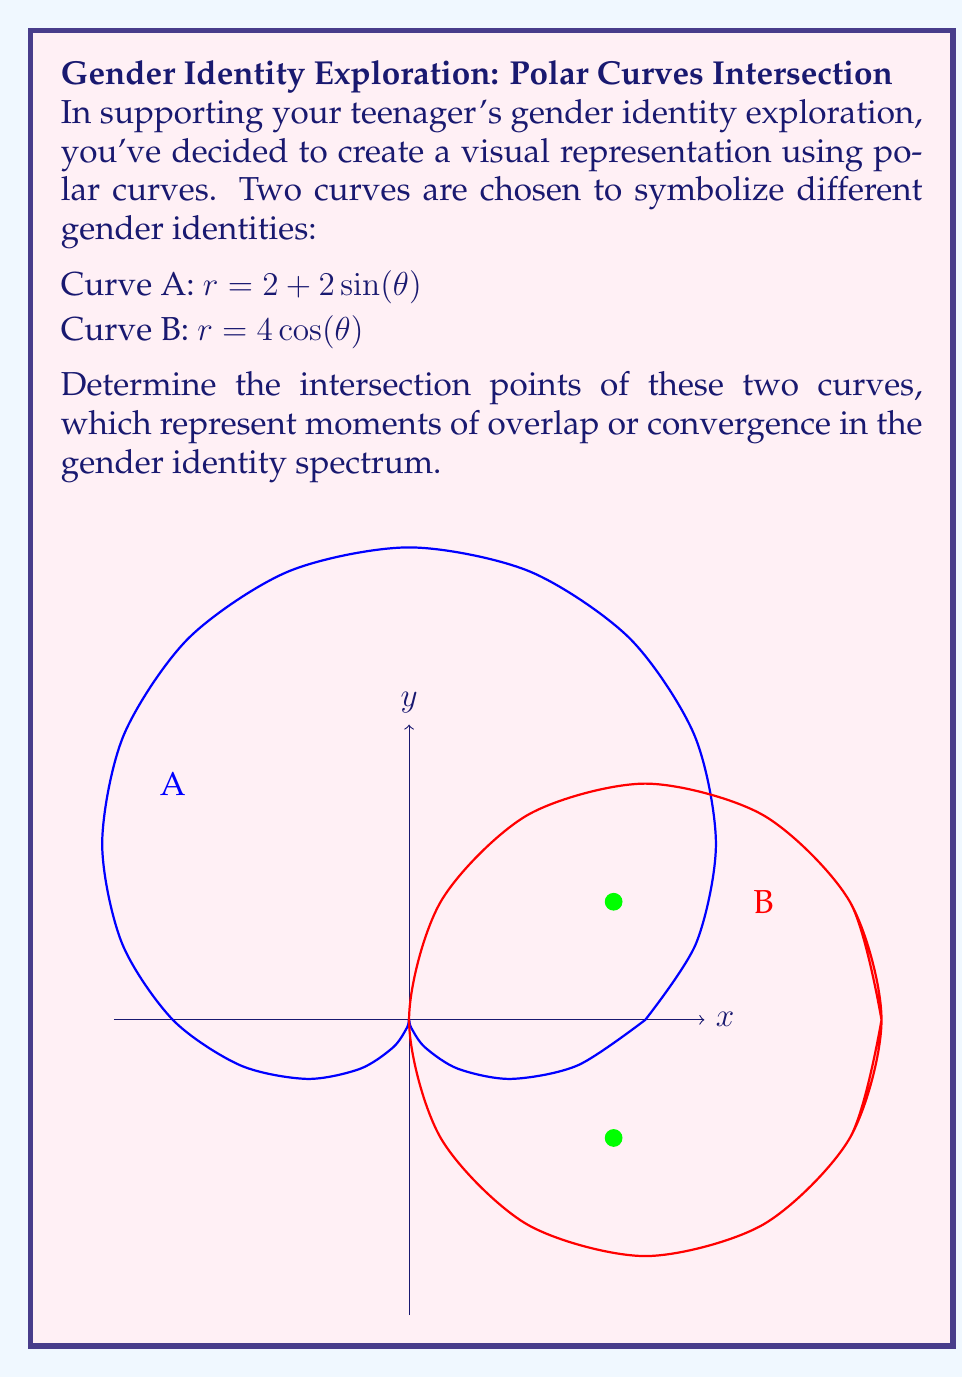Give your solution to this math problem. To find the intersection points, we need to solve the equation:

$$ 2 + 2\sin(\theta) = 4\cos(\theta) $$

Step 1: Rearrange the equation
$$ 2\sin(\theta) + 4\cos(\theta) = 2 $$

Step 2: Divide both sides by 2
$$ \sin(\theta) + 2\cos(\theta) = 1 $$

Step 3: Use the substitution $\cos(\theta) = t$ and $\sin(\theta) = \sqrt{1-t^2}$
$$ \sqrt{1-t^2} + 2t = 1 $$

Step 4: Square both sides
$$ 1-t^2 + 4t^2 + 4t\sqrt{1-t^2} = 1 $$

Step 5: Simplify
$$ 3t^2 + 4t\sqrt{1-t^2} = 0 $$

Step 6: Factor out $t$
$$ t(3t + 4\sqrt{1-t^2}) = 0 $$

Step 7: Solve the equation
Either $t = 0$ or $3t + 4\sqrt{1-t^2} = 0$

For $t = 0$, $\theta = \pm\frac{\pi}{2}$, but this doesn't satisfy the original equation.

For $3t + 4\sqrt{1-t^2} = 0$, solve:
$$ 9t^2 = 16(1-t^2) $$
$$ 25t^2 = 16 $$
$$ t^2 = \frac{16}{25} = (\frac{4}{5})^2 $$
$$ t = \pm\frac{4}{5} $$

Step 8: Convert back to $\theta$
$$ \cos(\theta) = \pm\frac{4}{5} $$
$$ \theta = \pm\arccos(\frac{4}{5}) = \pm\frac{\pi}{6} $$

Step 9: Calculate $r$ at these points
$$ r = 2 + 2\sin(\frac{\pi}{6}) = 2 + 2(\frac{1}{2}) = 3 $$

Therefore, the intersection points are $(3, \frac{\pi}{6})$ and $(3, -\frac{\pi}{6})$ in polar coordinates, or $(2\sqrt{3}, 1)$ and $(2\sqrt{3}, -1)$ in Cartesian coordinates.
Answer: $(3, \frac{\pi}{6})$ and $(3, -\frac{\pi}{6})$ in polar coordinates 